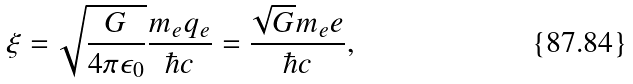Convert formula to latex. <formula><loc_0><loc_0><loc_500><loc_500>\xi = \sqrt { \frac { G } { 4 \pi \epsilon _ { 0 } } } \frac { m _ { e } q _ { e } } { \hbar { c } } = \frac { \sqrt { G } m _ { e } e } { \hbar { c } } ,</formula> 